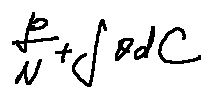Convert formula to latex. <formula><loc_0><loc_0><loc_500><loc_500>\frac { p } { N } + \int \theta d C</formula> 